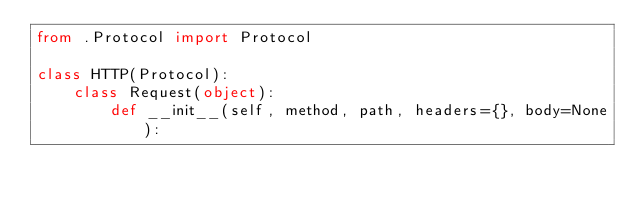Convert code to text. <code><loc_0><loc_0><loc_500><loc_500><_Python_>from .Protocol import Protocol

class HTTP(Protocol):
    class Request(object):
        def __init__(self, method, path, headers={}, body=None):</code> 